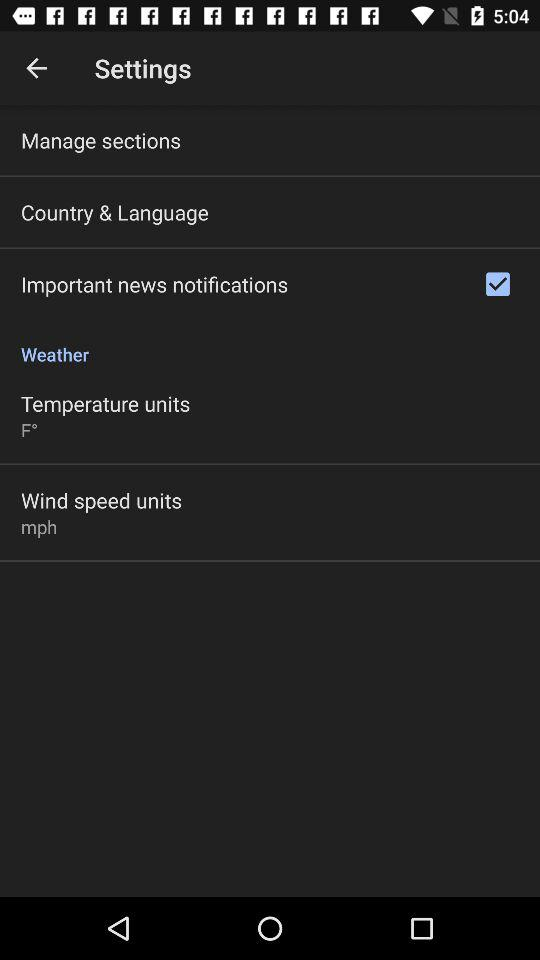What is the selected unit of temperature? The selected unit of temperature is F°. 